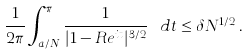Convert formula to latex. <formula><loc_0><loc_0><loc_500><loc_500>\frac { 1 } { 2 \pi } \int _ { a / N } ^ { \pi } \frac { 1 } { | 1 - R e ^ { i t } | ^ { 3 / 2 } } \ d t \leq \delta N ^ { 1 / 2 } \, .</formula> 